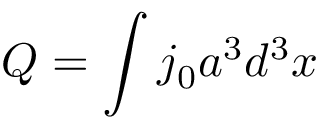Convert formula to latex. <formula><loc_0><loc_0><loc_500><loc_500>Q = \int j _ { 0 } a ^ { 3 } d ^ { 3 } x</formula> 